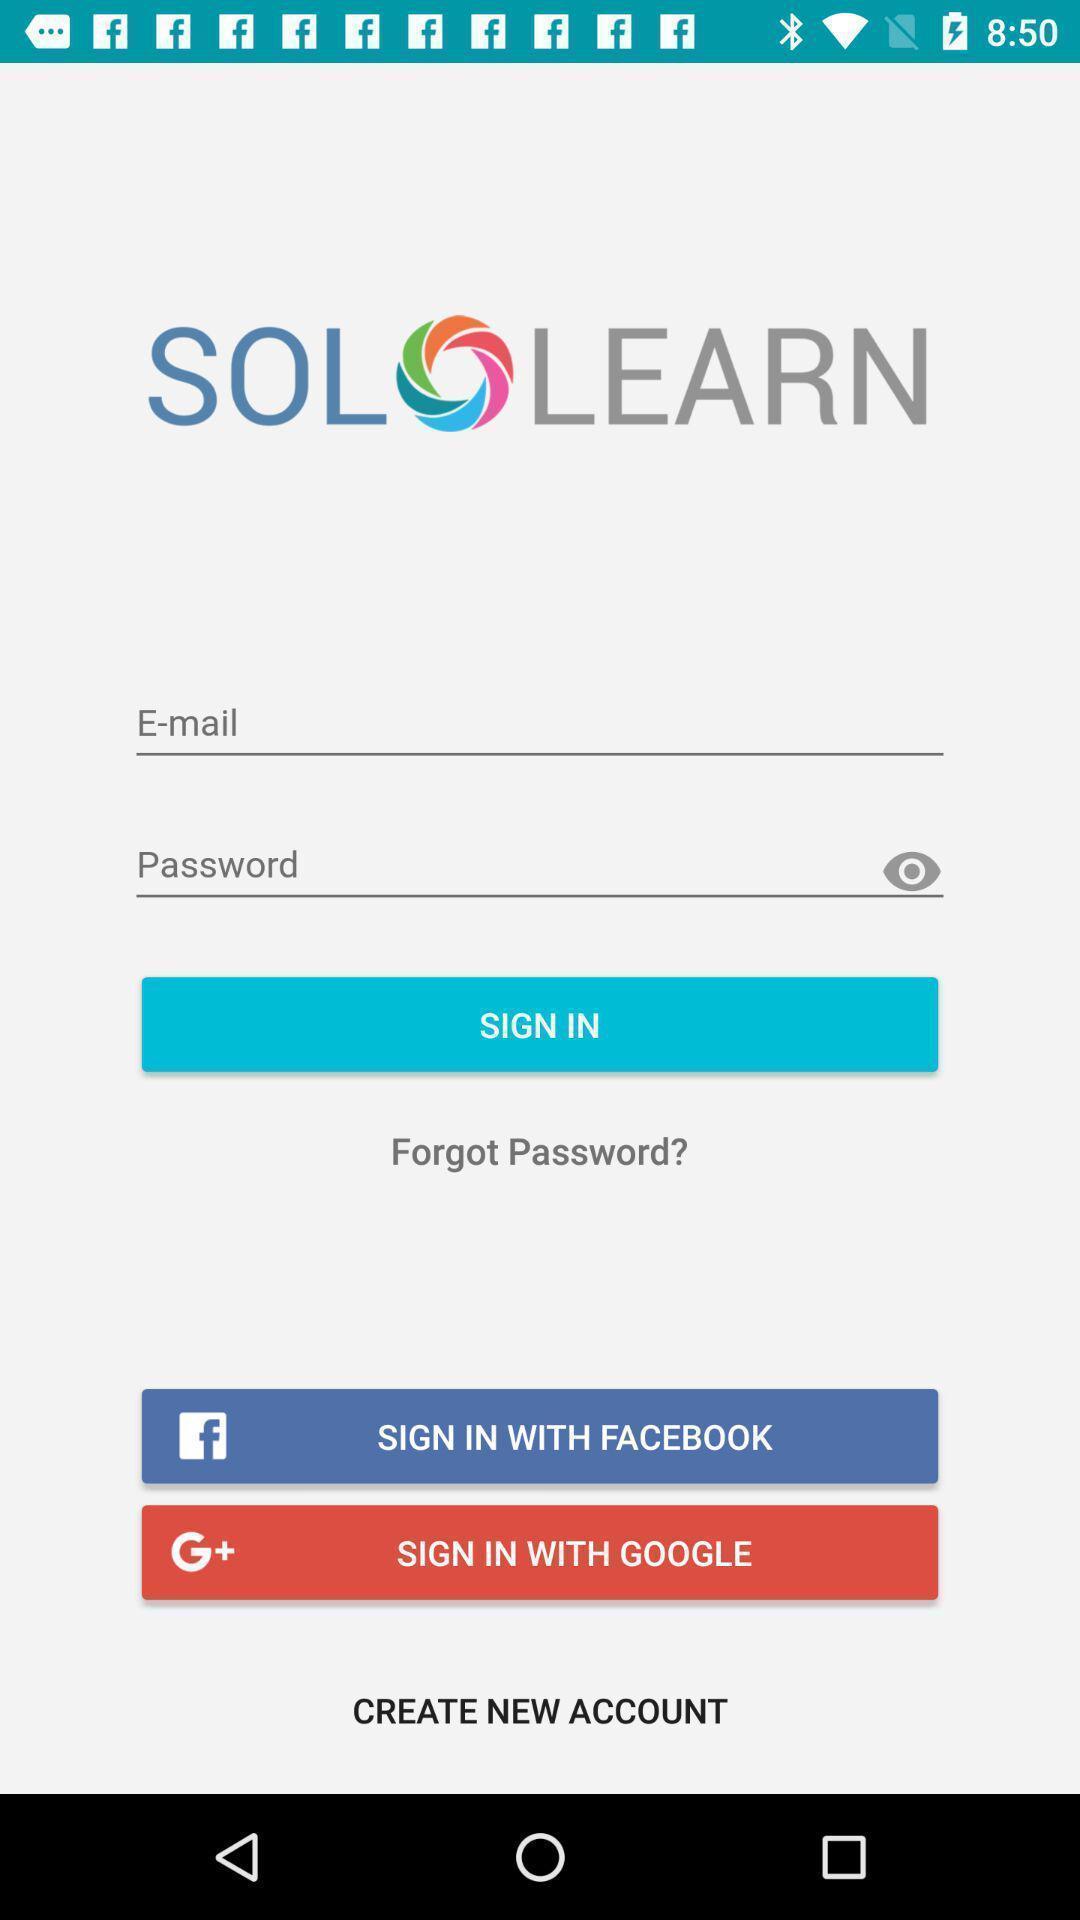Summarize the main components in this picture. Sign in page through social apps for learning application. 